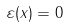Convert formula to latex. <formula><loc_0><loc_0><loc_500><loc_500>\varepsilon ( x ) = 0 \quad</formula> 